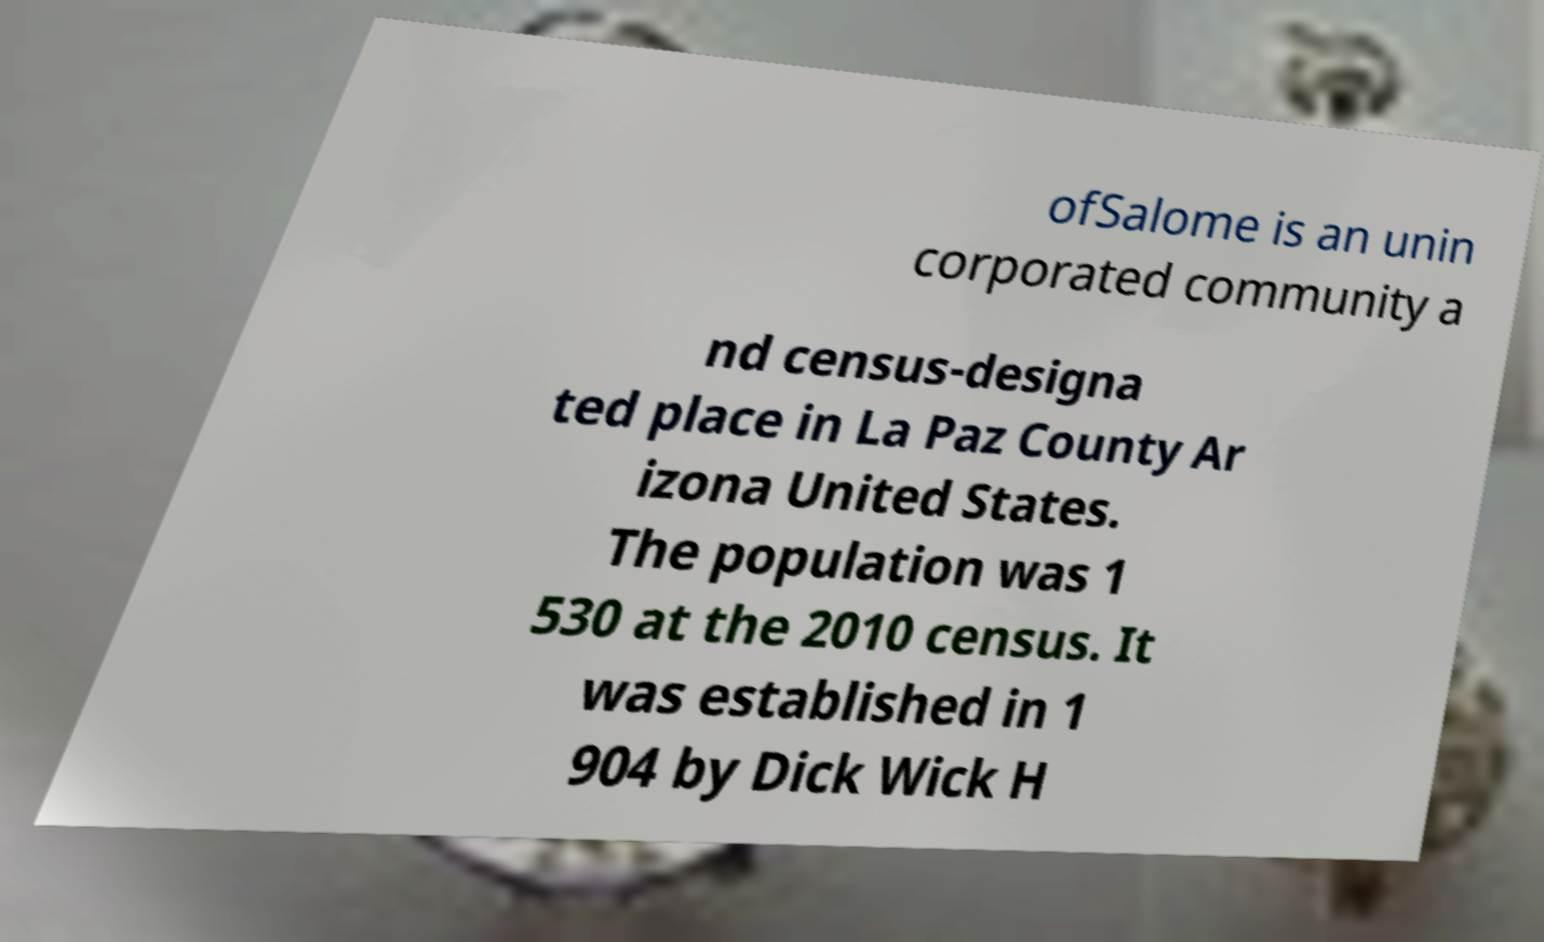Can you accurately transcribe the text from the provided image for me? ofSalome is an unin corporated community a nd census-designa ted place in La Paz County Ar izona United States. The population was 1 530 at the 2010 census. It was established in 1 904 by Dick Wick H 